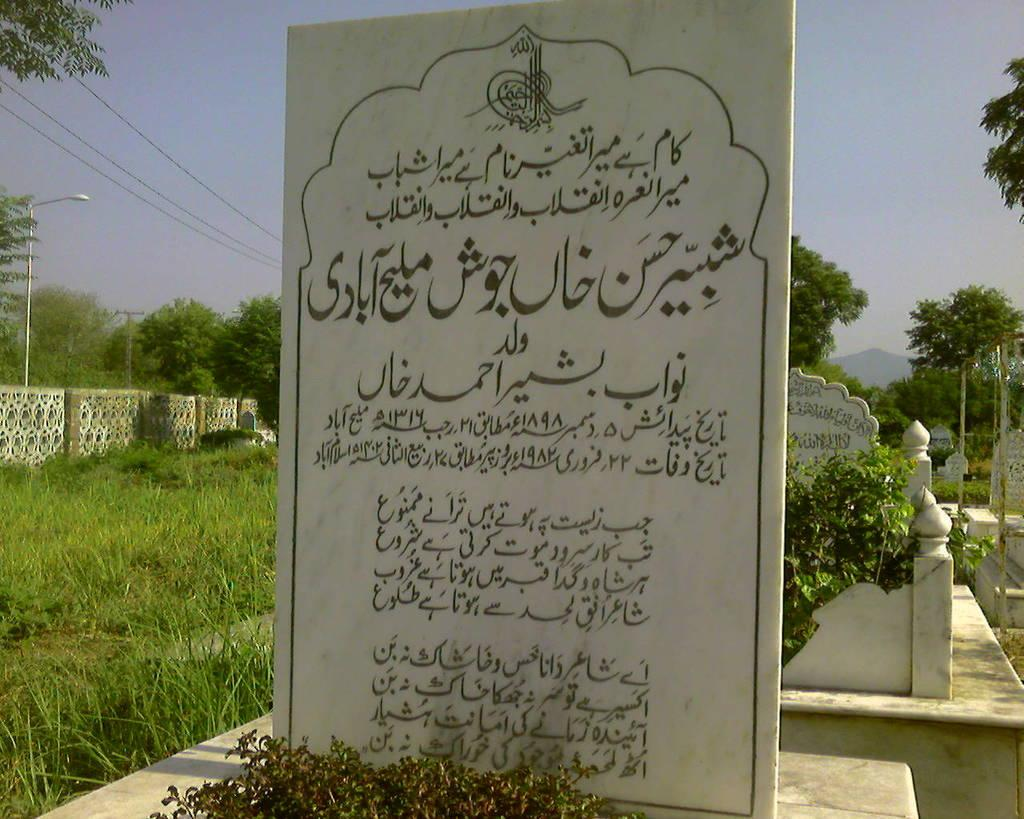What is the main subject of the picture? The main subject of the picture is a gravestone. What can be read on the gravestone? There is writing on the gravestone. What is present on the left side of the gravestone? There is grass and a wall on the left side of the gravestone. What type of vegetation can be seen in the picture? There are trees and plants in the picture. How would you describe the weather in the image? The sky is clear in the image, suggesting good weather. Can you tell me how many nuts the monkey is holding in the image? There is no monkey or nuts present in the image; it features a gravestone with writing and surrounding vegetation. What type of lock is securing the gravestone in the image? There is no lock present on the gravestone in the image. 